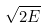<formula> <loc_0><loc_0><loc_500><loc_500>\sqrt { 2 E }</formula> 